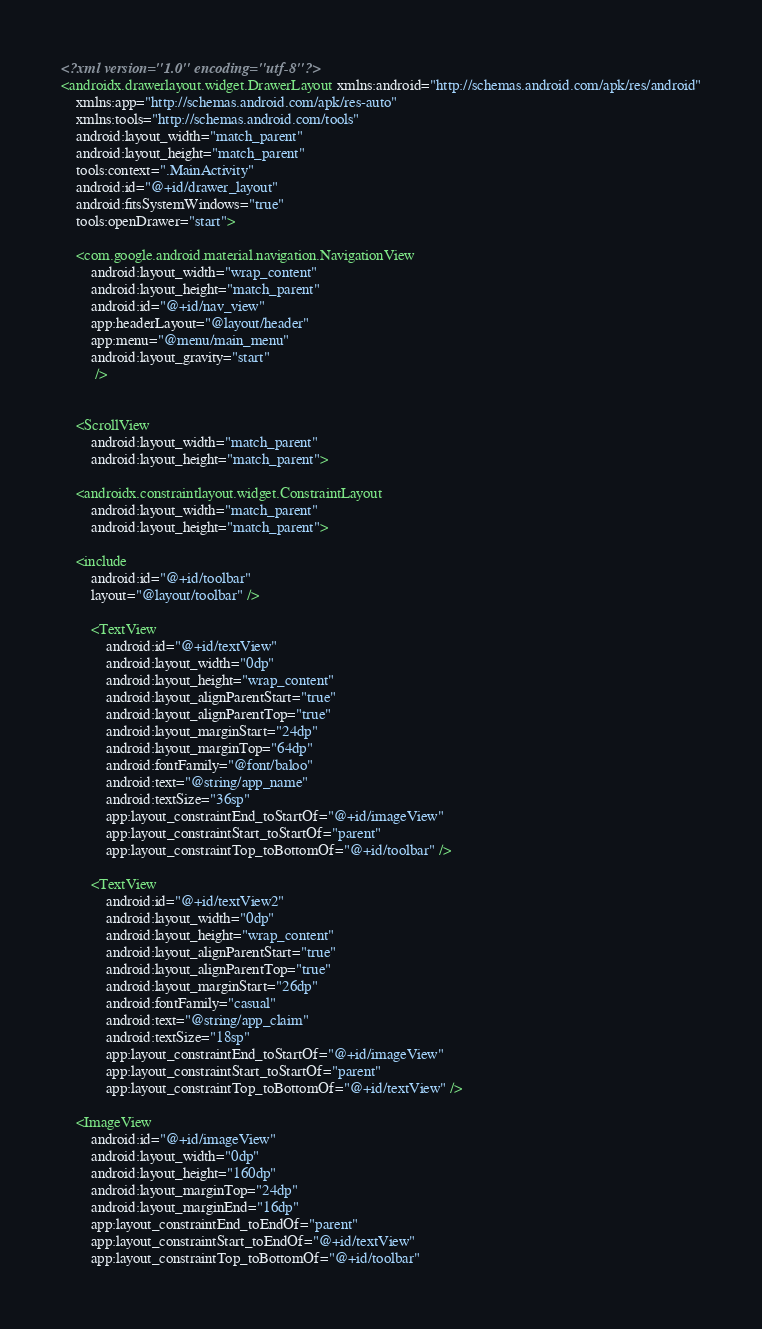<code> <loc_0><loc_0><loc_500><loc_500><_XML_><?xml version="1.0" encoding="utf-8"?>
<androidx.drawerlayout.widget.DrawerLayout xmlns:android="http://schemas.android.com/apk/res/android"
    xmlns:app="http://schemas.android.com/apk/res-auto"
    xmlns:tools="http://schemas.android.com/tools"
    android:layout_width="match_parent"
    android:layout_height="match_parent"
    tools:context=".MainActivity"
    android:id="@+id/drawer_layout"
    android:fitsSystemWindows="true"
    tools:openDrawer="start">

    <com.google.android.material.navigation.NavigationView
        android:layout_width="wrap_content"
        android:layout_height="match_parent"
        android:id="@+id/nav_view"
        app:headerLayout="@layout/header"
        app:menu="@menu/main_menu"
        android:layout_gravity="start"
         />


    <ScrollView
        android:layout_width="match_parent"
        android:layout_height="match_parent">

    <androidx.constraintlayout.widget.ConstraintLayout
        android:layout_width="match_parent"
        android:layout_height="match_parent">

    <include
        android:id="@+id/toolbar"
        layout="@layout/toolbar" />

        <TextView
            android:id="@+id/textView"
            android:layout_width="0dp"
            android:layout_height="wrap_content"
            android:layout_alignParentStart="true"
            android:layout_alignParentTop="true"
            android:layout_marginStart="24dp"
            android:layout_marginTop="64dp"
            android:fontFamily="@font/baloo"
            android:text="@string/app_name"
            android:textSize="36sp"
            app:layout_constraintEnd_toStartOf="@+id/imageView"
            app:layout_constraintStart_toStartOf="parent"
            app:layout_constraintTop_toBottomOf="@+id/toolbar" />

        <TextView
            android:id="@+id/textView2"
            android:layout_width="0dp"
            android:layout_height="wrap_content"
            android:layout_alignParentStart="true"
            android:layout_alignParentTop="true"
            android:layout_marginStart="26dp"
            android:fontFamily="casual"
            android:text="@string/app_claim"
            android:textSize="18sp"
            app:layout_constraintEnd_toStartOf="@+id/imageView"
            app:layout_constraintStart_toStartOf="parent"
            app:layout_constraintTop_toBottomOf="@+id/textView" />

    <ImageView
        android:id="@+id/imageView"
        android:layout_width="0dp"
        android:layout_height="160dp"
        android:layout_marginTop="24dp"
        android:layout_marginEnd="16dp"
        app:layout_constraintEnd_toEndOf="parent"
        app:layout_constraintStart_toEndOf="@+id/textView"
        app:layout_constraintTop_toBottomOf="@+id/toolbar"</code> 